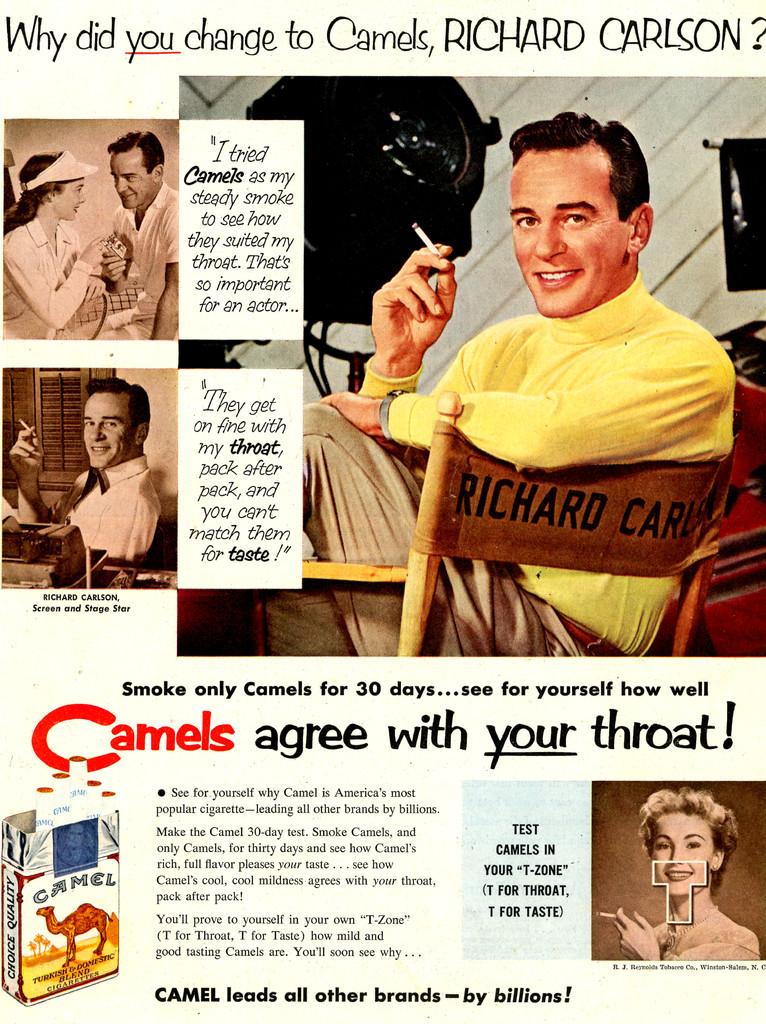What do these agree with?
Provide a short and direct response. Your throat. 